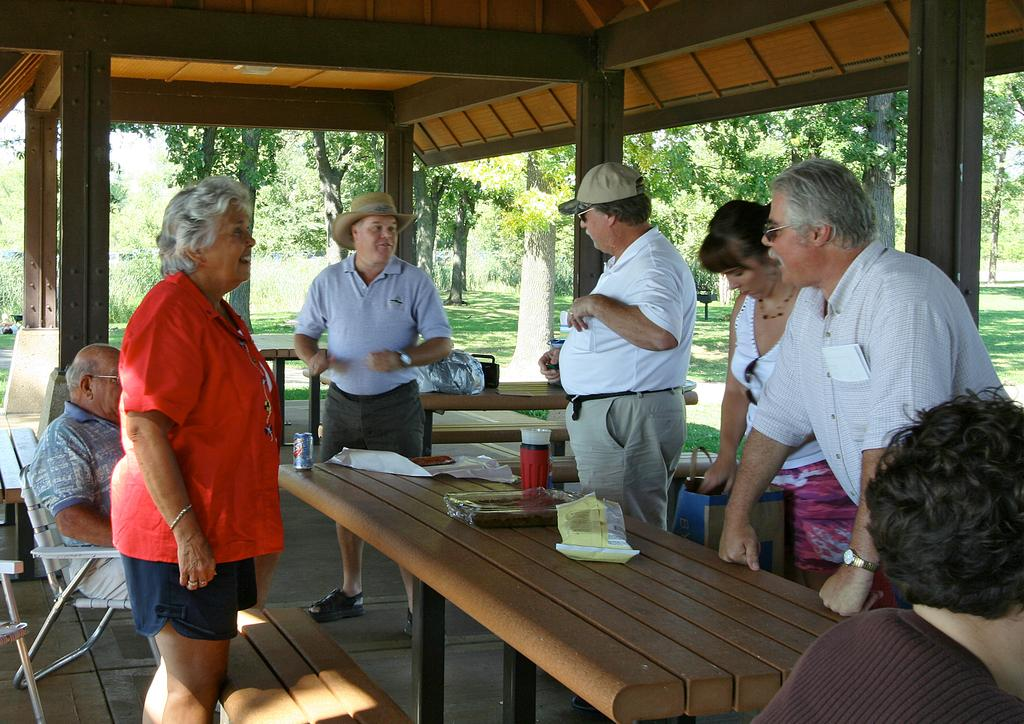How many people are standing on the right side of the image? There are four people standing on the right side of the image. What are the people on the right side of the image doing? The people on the right side of the image are talking. What can be seen behind the people on the right side of the image? There are trees behind the people on the right side of the image. What is the woman on the left side of the image wearing? The woman on the left side of the image is wearing a red T-shirt. What type of fuel is being used by the chicken in the image? There is no chicken present in the image, so it is not possible to determine what type of fuel it might be using. 